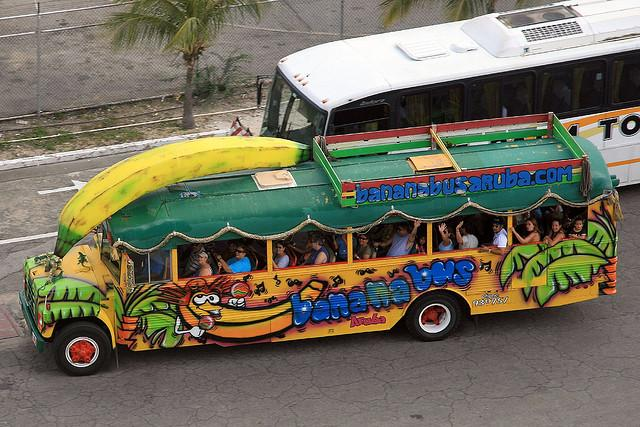Which one of these is a sister island to this location? curacao 